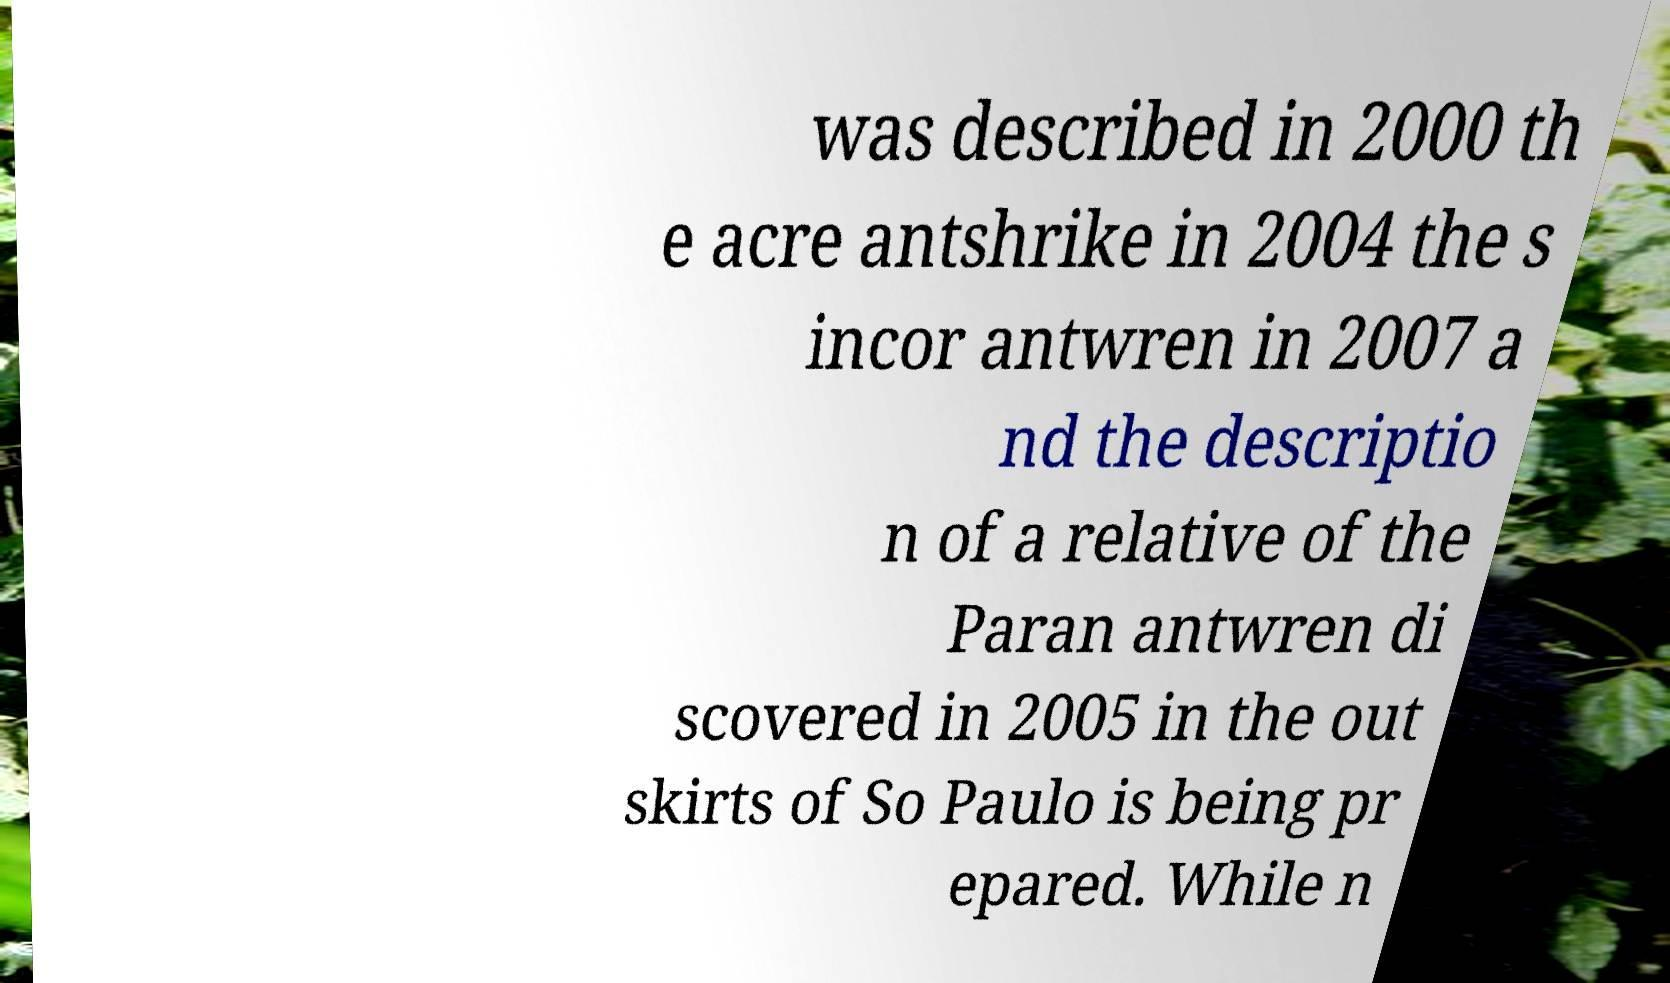Can you accurately transcribe the text from the provided image for me? was described in 2000 th e acre antshrike in 2004 the s incor antwren in 2007 a nd the descriptio n of a relative of the Paran antwren di scovered in 2005 in the out skirts of So Paulo is being pr epared. While n 